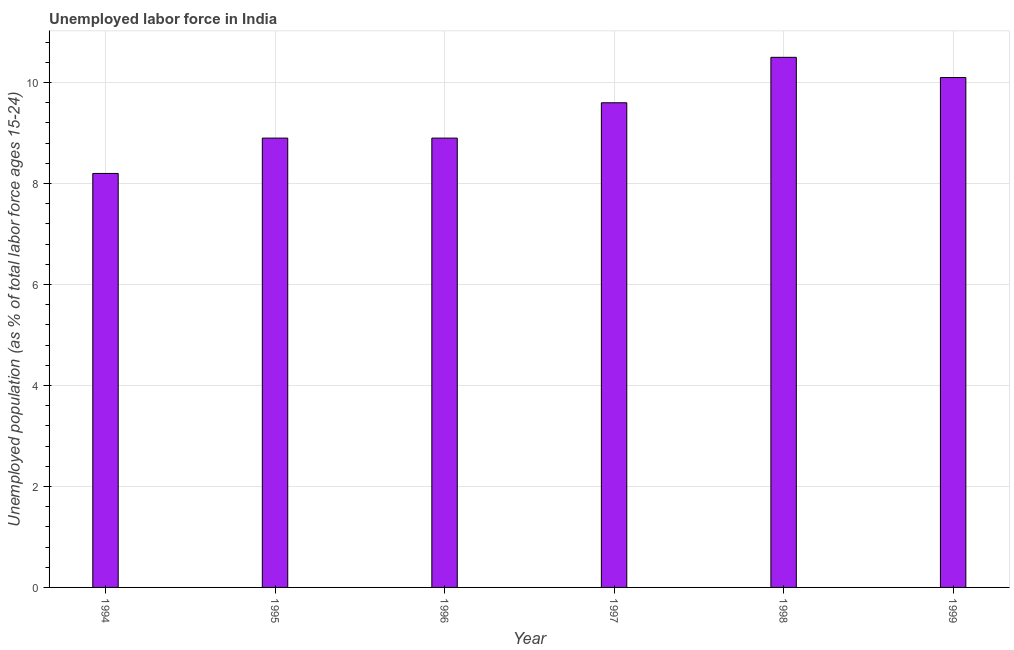Does the graph contain any zero values?
Provide a short and direct response. No. What is the title of the graph?
Ensure brevity in your answer.  Unemployed labor force in India. What is the label or title of the Y-axis?
Ensure brevity in your answer.  Unemployed population (as % of total labor force ages 15-24). What is the total unemployed youth population in 1994?
Provide a short and direct response. 8.2. Across all years, what is the minimum total unemployed youth population?
Your answer should be compact. 8.2. In which year was the total unemployed youth population maximum?
Provide a succinct answer. 1998. What is the sum of the total unemployed youth population?
Provide a succinct answer. 56.2. What is the difference between the total unemployed youth population in 1996 and 1998?
Give a very brief answer. -1.6. What is the average total unemployed youth population per year?
Provide a succinct answer. 9.37. What is the median total unemployed youth population?
Your answer should be compact. 9.25. Do a majority of the years between 1998 and 1997 (inclusive) have total unemployed youth population greater than 6.8 %?
Keep it short and to the point. No. What is the ratio of the total unemployed youth population in 1998 to that in 1999?
Your response must be concise. 1.04. Is the difference between the total unemployed youth population in 1994 and 1997 greater than the difference between any two years?
Your answer should be very brief. No. What is the difference between the highest and the second highest total unemployed youth population?
Your response must be concise. 0.4. Is the sum of the total unemployed youth population in 1994 and 1999 greater than the maximum total unemployed youth population across all years?
Your answer should be very brief. Yes. In how many years, is the total unemployed youth population greater than the average total unemployed youth population taken over all years?
Your answer should be compact. 3. How many bars are there?
Offer a terse response. 6. Are all the bars in the graph horizontal?
Your response must be concise. No. How many years are there in the graph?
Make the answer very short. 6. Are the values on the major ticks of Y-axis written in scientific E-notation?
Your answer should be compact. No. What is the Unemployed population (as % of total labor force ages 15-24) in 1994?
Ensure brevity in your answer.  8.2. What is the Unemployed population (as % of total labor force ages 15-24) in 1995?
Offer a very short reply. 8.9. What is the Unemployed population (as % of total labor force ages 15-24) of 1996?
Provide a short and direct response. 8.9. What is the Unemployed population (as % of total labor force ages 15-24) in 1997?
Offer a very short reply. 9.6. What is the Unemployed population (as % of total labor force ages 15-24) of 1998?
Your answer should be very brief. 10.5. What is the Unemployed population (as % of total labor force ages 15-24) of 1999?
Your answer should be compact. 10.1. What is the difference between the Unemployed population (as % of total labor force ages 15-24) in 1994 and 1995?
Offer a terse response. -0.7. What is the difference between the Unemployed population (as % of total labor force ages 15-24) in 1994 and 1996?
Provide a succinct answer. -0.7. What is the difference between the Unemployed population (as % of total labor force ages 15-24) in 1995 and 1996?
Make the answer very short. 0. What is the difference between the Unemployed population (as % of total labor force ages 15-24) in 1995 and 1997?
Offer a very short reply. -0.7. What is the difference between the Unemployed population (as % of total labor force ages 15-24) in 1995 and 1998?
Keep it short and to the point. -1.6. What is the difference between the Unemployed population (as % of total labor force ages 15-24) in 1995 and 1999?
Provide a succinct answer. -1.2. What is the difference between the Unemployed population (as % of total labor force ages 15-24) in 1996 and 1997?
Offer a very short reply. -0.7. What is the difference between the Unemployed population (as % of total labor force ages 15-24) in 1996 and 1998?
Offer a terse response. -1.6. What is the difference between the Unemployed population (as % of total labor force ages 15-24) in 1997 and 1998?
Provide a succinct answer. -0.9. What is the difference between the Unemployed population (as % of total labor force ages 15-24) in 1997 and 1999?
Your answer should be compact. -0.5. What is the difference between the Unemployed population (as % of total labor force ages 15-24) in 1998 and 1999?
Ensure brevity in your answer.  0.4. What is the ratio of the Unemployed population (as % of total labor force ages 15-24) in 1994 to that in 1995?
Offer a terse response. 0.92. What is the ratio of the Unemployed population (as % of total labor force ages 15-24) in 1994 to that in 1996?
Your response must be concise. 0.92. What is the ratio of the Unemployed population (as % of total labor force ages 15-24) in 1994 to that in 1997?
Give a very brief answer. 0.85. What is the ratio of the Unemployed population (as % of total labor force ages 15-24) in 1994 to that in 1998?
Provide a succinct answer. 0.78. What is the ratio of the Unemployed population (as % of total labor force ages 15-24) in 1994 to that in 1999?
Ensure brevity in your answer.  0.81. What is the ratio of the Unemployed population (as % of total labor force ages 15-24) in 1995 to that in 1997?
Your response must be concise. 0.93. What is the ratio of the Unemployed population (as % of total labor force ages 15-24) in 1995 to that in 1998?
Make the answer very short. 0.85. What is the ratio of the Unemployed population (as % of total labor force ages 15-24) in 1995 to that in 1999?
Offer a terse response. 0.88. What is the ratio of the Unemployed population (as % of total labor force ages 15-24) in 1996 to that in 1997?
Make the answer very short. 0.93. What is the ratio of the Unemployed population (as % of total labor force ages 15-24) in 1996 to that in 1998?
Your answer should be very brief. 0.85. What is the ratio of the Unemployed population (as % of total labor force ages 15-24) in 1996 to that in 1999?
Your response must be concise. 0.88. What is the ratio of the Unemployed population (as % of total labor force ages 15-24) in 1997 to that in 1998?
Your answer should be compact. 0.91. What is the ratio of the Unemployed population (as % of total labor force ages 15-24) in 1998 to that in 1999?
Make the answer very short. 1.04. 